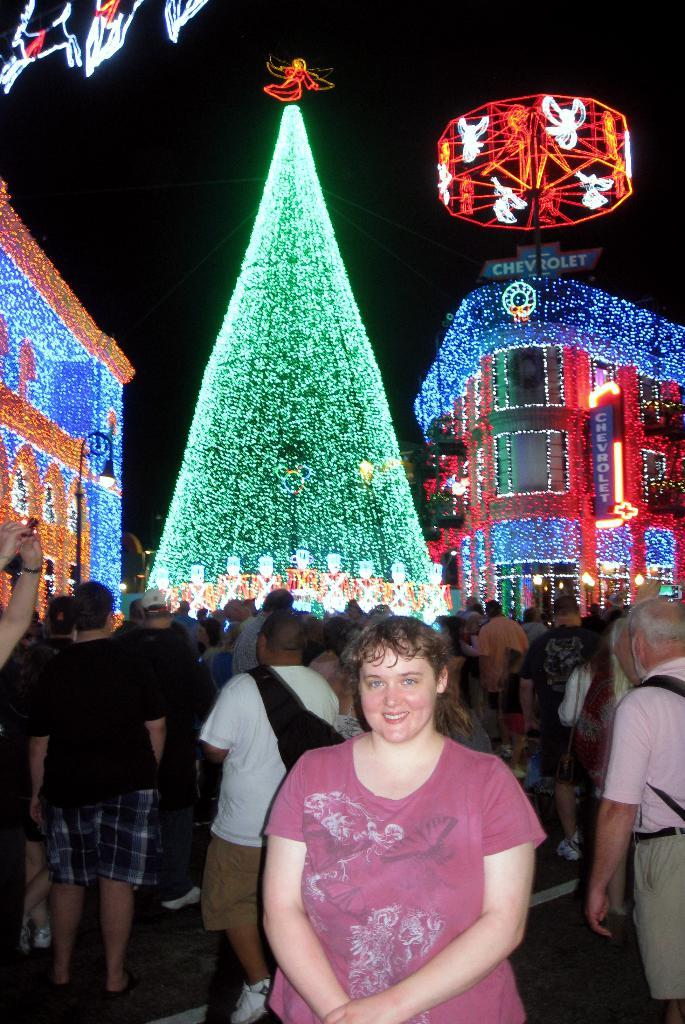What are the people in the image doing? The group of people is standing on the road. What can be seen in the background of the image? There are buildings with lights and a street pole in the background. Is there any signage or noticeable object in the background? Yes, there is a board in the background. What is the existence of the man in the image? There is no mention of a man in the image, so it cannot be determined if there is an existence of a man. 